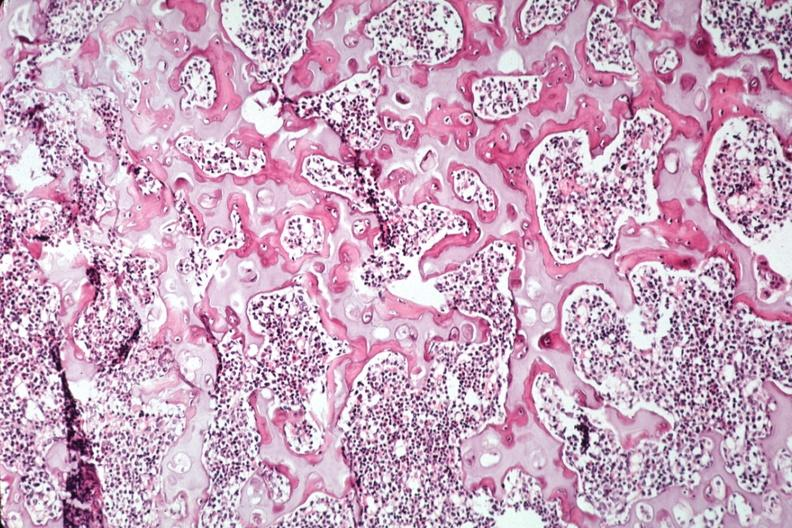does this image show nice photo of ossifying trabecular bone?
Answer the question using a single word or phrase. Yes 